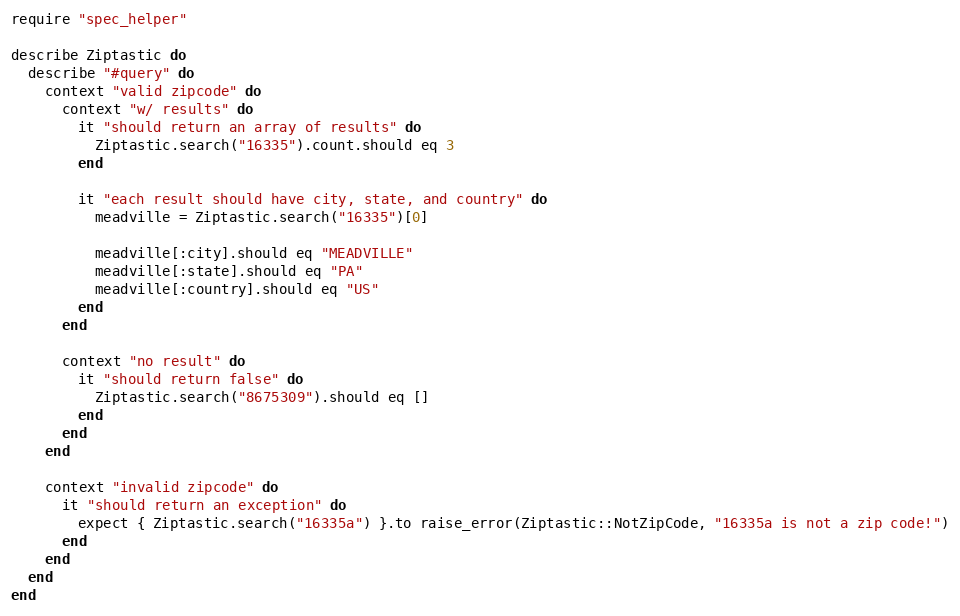<code> <loc_0><loc_0><loc_500><loc_500><_Ruby_>require "spec_helper"

describe Ziptastic do
  describe "#query" do
    context "valid zipcode" do 
      context "w/ results" do      
        it "should return an array of results" do
          Ziptastic.search("16335").count.should eq 3
        end
      
        it "each result should have city, state, and country" do
          meadville = Ziptastic.search("16335")[0]
          
          meadville[:city].should eq "MEADVILLE"
          meadville[:state].should eq "PA"
          meadville[:country].should eq "US"
        end
      end
      
      context "no result" do
        it "should return false" do
          Ziptastic.search("8675309").should eq []
        end
      end
    end
        
    context "invalid zipcode" do
      it "should return an exception" do
        expect { Ziptastic.search("16335a") }.to raise_error(Ziptastic::NotZipCode, "16335a is not a zip code!")
      end
    end
  end
end
</code> 